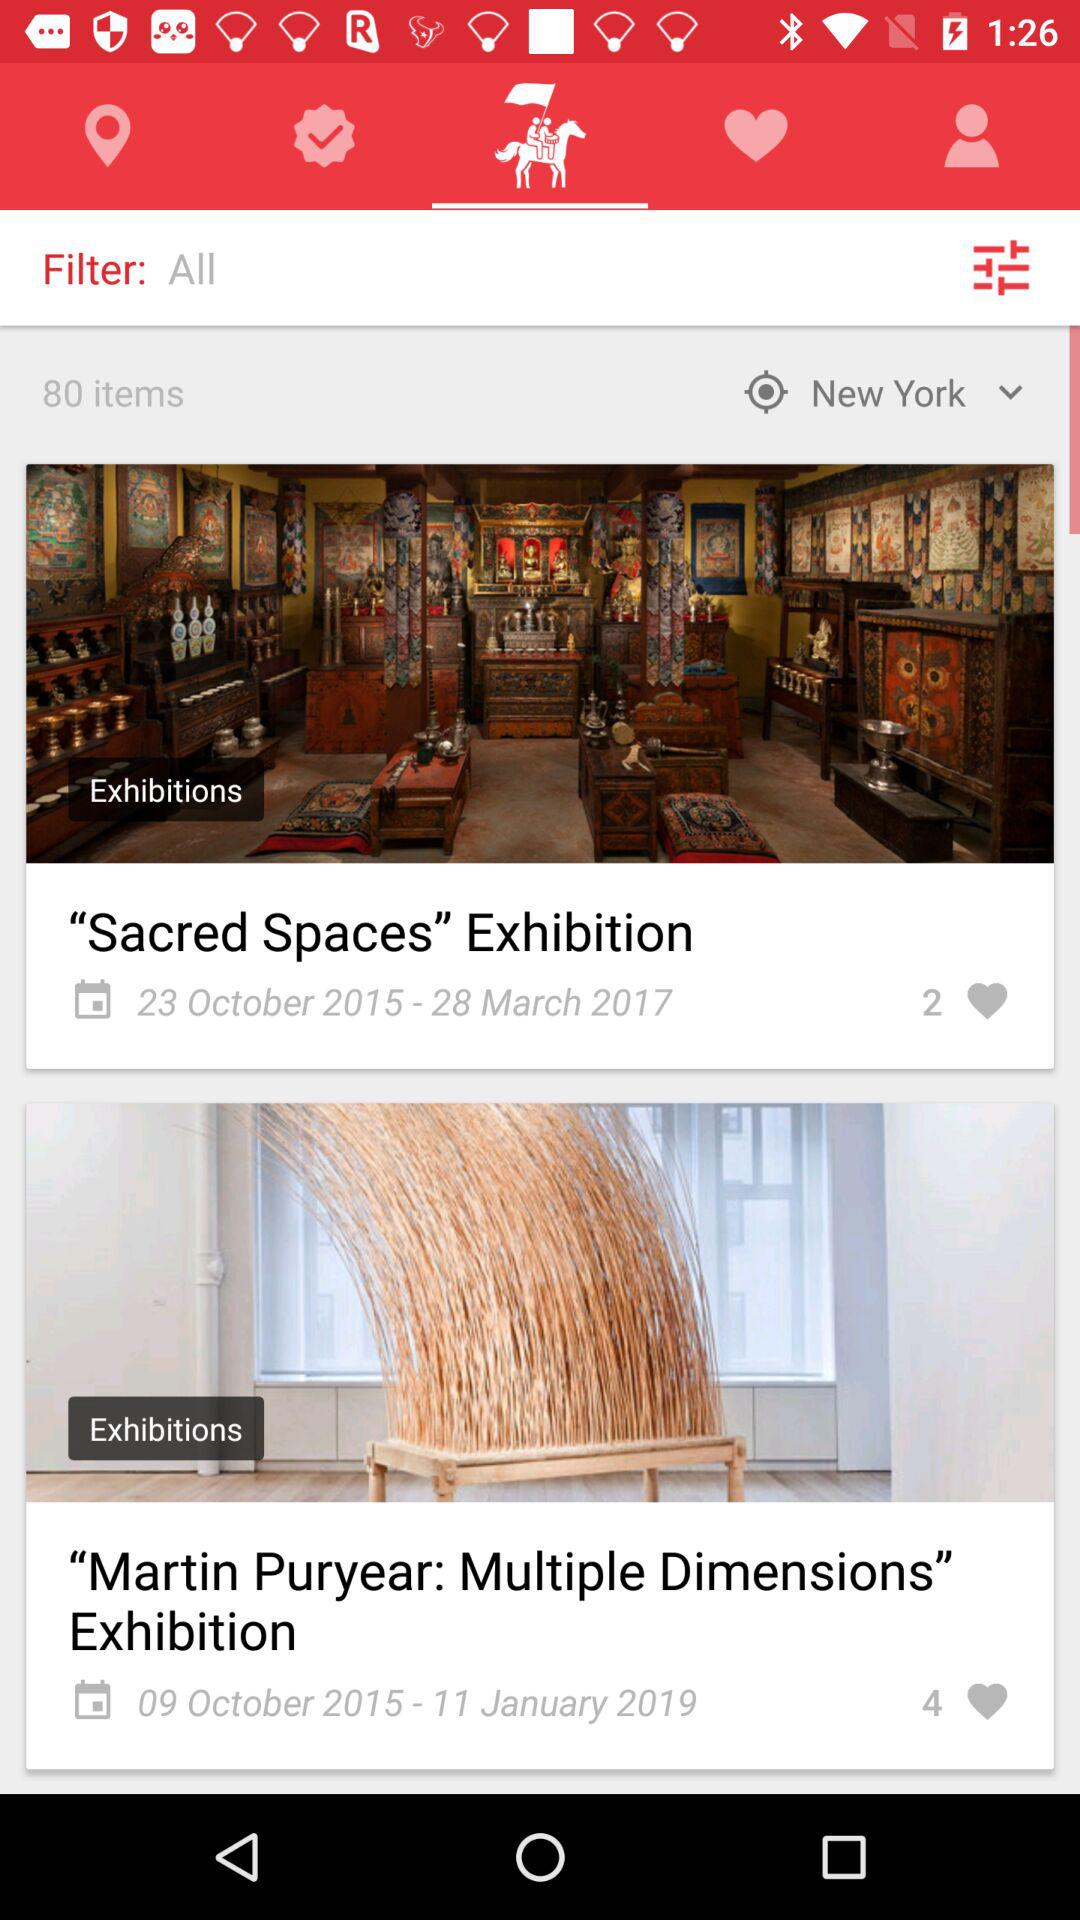How many likes are there on "Martin Puryear: Multiple Dimensions"? There are 4 likes. 